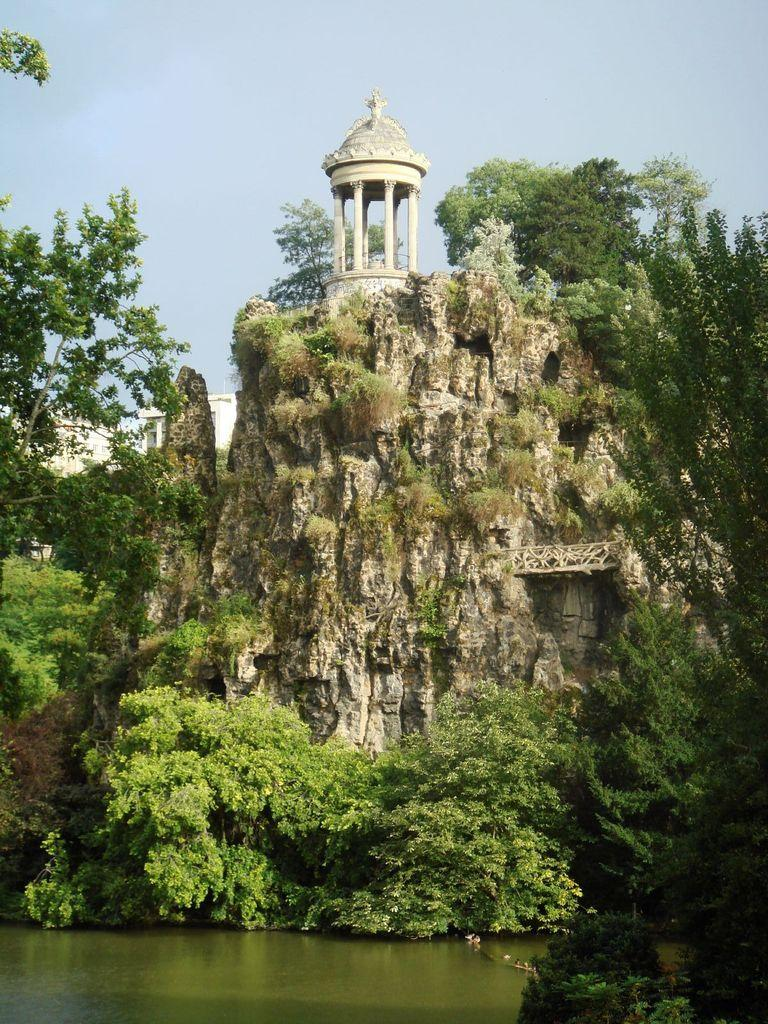What type of natural elements can be seen in the image? There are rocks and trees in the image. What type of man-made structures are present in the image? There are buildings in the image. What part of the natural environment is visible in the image? The sky is visible in the image. Can you see a man wearing a scarf in the image? There is no man wearing a scarf present in the image. Is there a battle taking place in the image? There is no battle depicted in the image. 